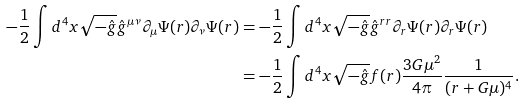Convert formula to latex. <formula><loc_0><loc_0><loc_500><loc_500>- \frac { 1 } { 2 } \int d ^ { 4 } x \sqrt { - \hat { g } } \hat { g } ^ { \mu \nu } \partial _ { \mu } \Psi ( r ) \partial _ { \nu } \Psi ( r ) & = - \frac { 1 } { 2 } \int d ^ { 4 } x \sqrt { - \hat { g } } \hat { g } ^ { r r } \partial _ { r } \Psi ( r ) \partial _ { r } \Psi ( r ) \\ & = - \frac { 1 } { 2 } \int d ^ { 4 } x \sqrt { - \hat { g } } f ( r ) \frac { 3 G \mu ^ { 2 } } { 4 \pi } \frac { 1 } { ( r + G \mu ) ^ { 4 } } .</formula> 